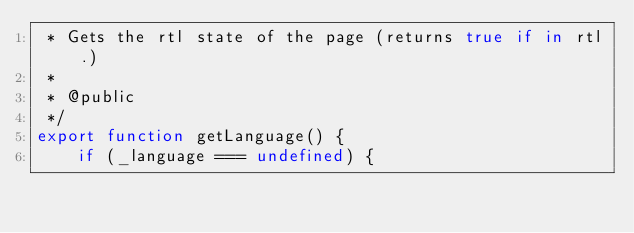Convert code to text. <code><loc_0><loc_0><loc_500><loc_500><_JavaScript_> * Gets the rtl state of the page (returns true if in rtl.)
 *
 * @public
 */
export function getLanguage() {
    if (_language === undefined) {</code> 